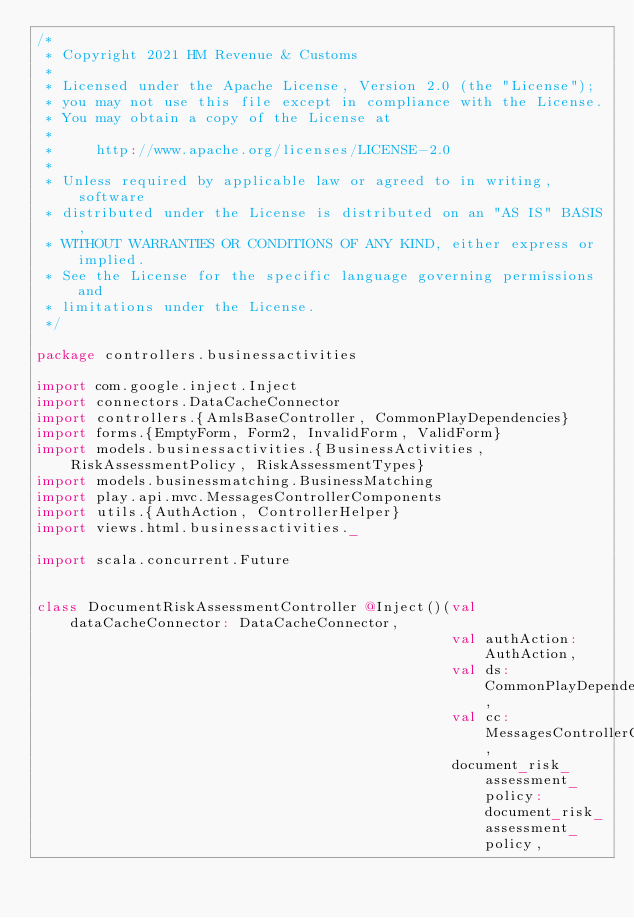<code> <loc_0><loc_0><loc_500><loc_500><_Scala_>/*
 * Copyright 2021 HM Revenue & Customs
 *
 * Licensed under the Apache License, Version 2.0 (the "License");
 * you may not use this file except in compliance with the License.
 * You may obtain a copy of the License at
 *
 *     http://www.apache.org/licenses/LICENSE-2.0
 *
 * Unless required by applicable law or agreed to in writing, software
 * distributed under the License is distributed on an "AS IS" BASIS,
 * WITHOUT WARRANTIES OR CONDITIONS OF ANY KIND, either express or implied.
 * See the License for the specific language governing permissions and
 * limitations under the License.
 */

package controllers.businessactivities

import com.google.inject.Inject
import connectors.DataCacheConnector
import controllers.{AmlsBaseController, CommonPlayDependencies}
import forms.{EmptyForm, Form2, InvalidForm, ValidForm}
import models.businessactivities.{BusinessActivities, RiskAssessmentPolicy, RiskAssessmentTypes}
import models.businessmatching.BusinessMatching
import play.api.mvc.MessagesControllerComponents
import utils.{AuthAction, ControllerHelper}
import views.html.businessactivities._

import scala.concurrent.Future


class DocumentRiskAssessmentController @Inject()(val dataCacheConnector: DataCacheConnector,
                                                 val authAction: AuthAction,
                                                 val ds: CommonPlayDependencies,
                                                 val cc: MessagesControllerComponents,
                                                 document_risk_assessment_policy: document_risk_assessment_policy,</code> 